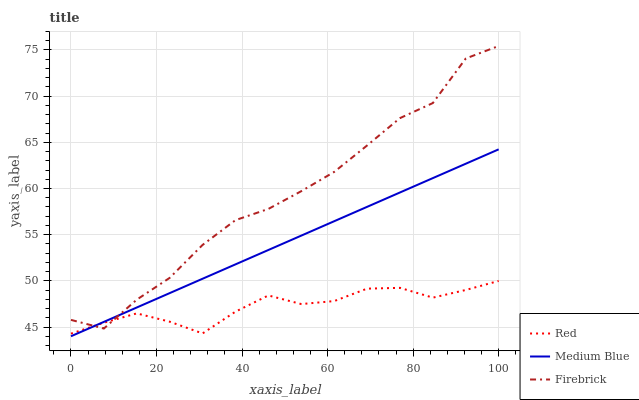Does Red have the minimum area under the curve?
Answer yes or no. Yes. Does Firebrick have the maximum area under the curve?
Answer yes or no. Yes. Does Medium Blue have the minimum area under the curve?
Answer yes or no. No. Does Medium Blue have the maximum area under the curve?
Answer yes or no. No. Is Medium Blue the smoothest?
Answer yes or no. Yes. Is Firebrick the roughest?
Answer yes or no. Yes. Is Red the smoothest?
Answer yes or no. No. Is Red the roughest?
Answer yes or no. No. Does Medium Blue have the lowest value?
Answer yes or no. Yes. Does Red have the lowest value?
Answer yes or no. No. Does Firebrick have the highest value?
Answer yes or no. Yes. Does Medium Blue have the highest value?
Answer yes or no. No. Does Medium Blue intersect Red?
Answer yes or no. Yes. Is Medium Blue less than Red?
Answer yes or no. No. Is Medium Blue greater than Red?
Answer yes or no. No. 